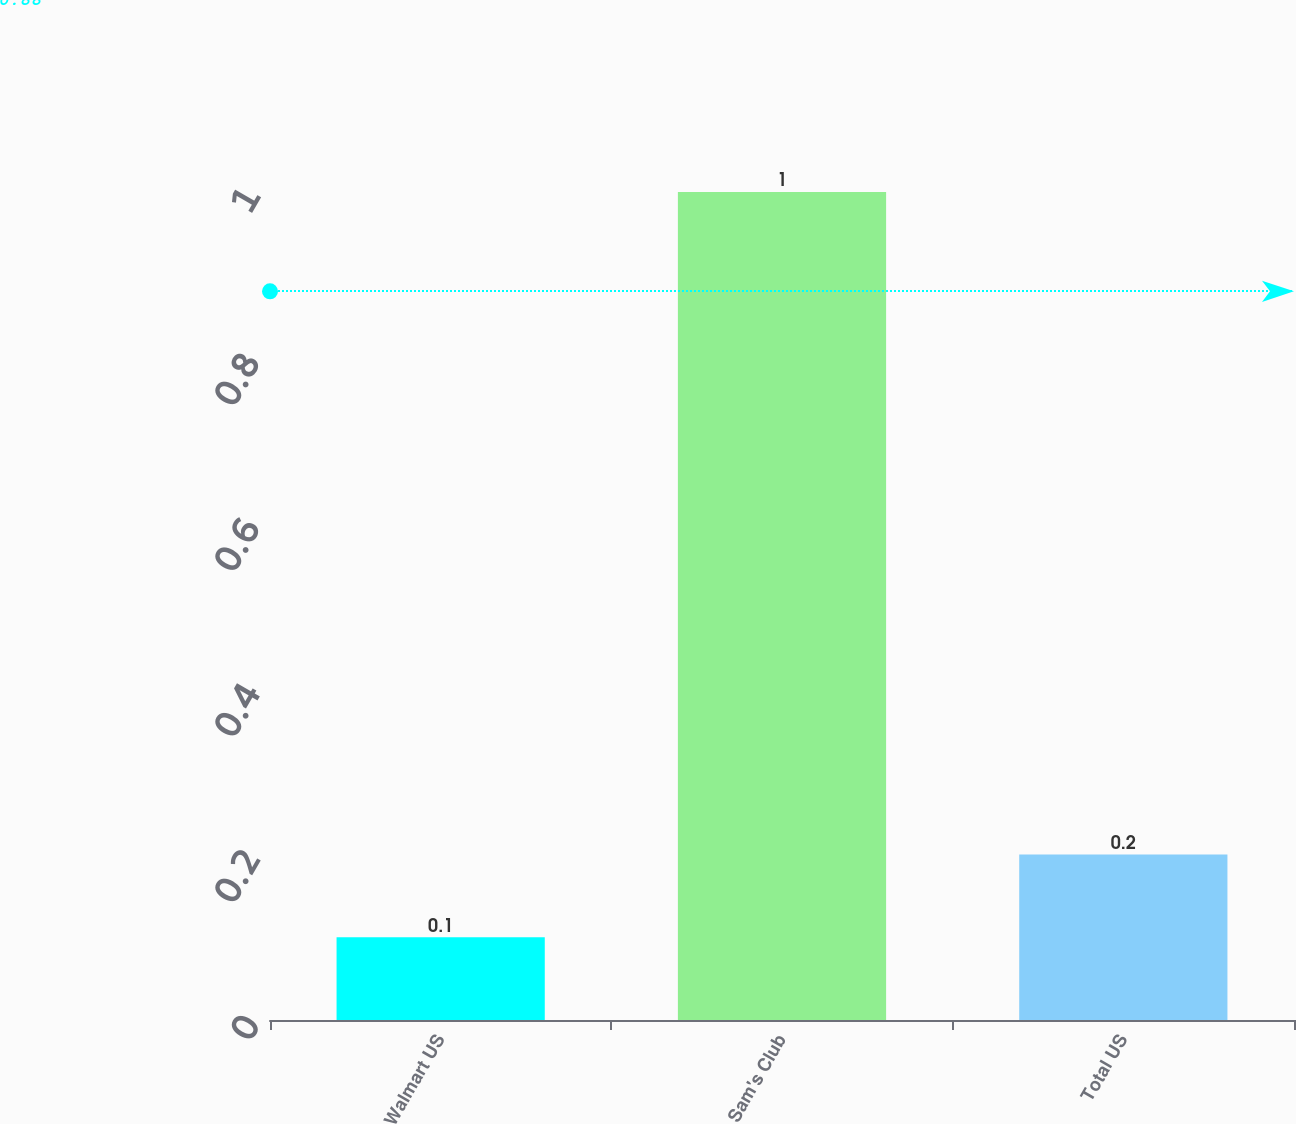Convert chart to OTSL. <chart><loc_0><loc_0><loc_500><loc_500><bar_chart><fcel>Walmart US<fcel>Sam's Club<fcel>Total US<nl><fcel>0.1<fcel>1<fcel>0.2<nl></chart> 